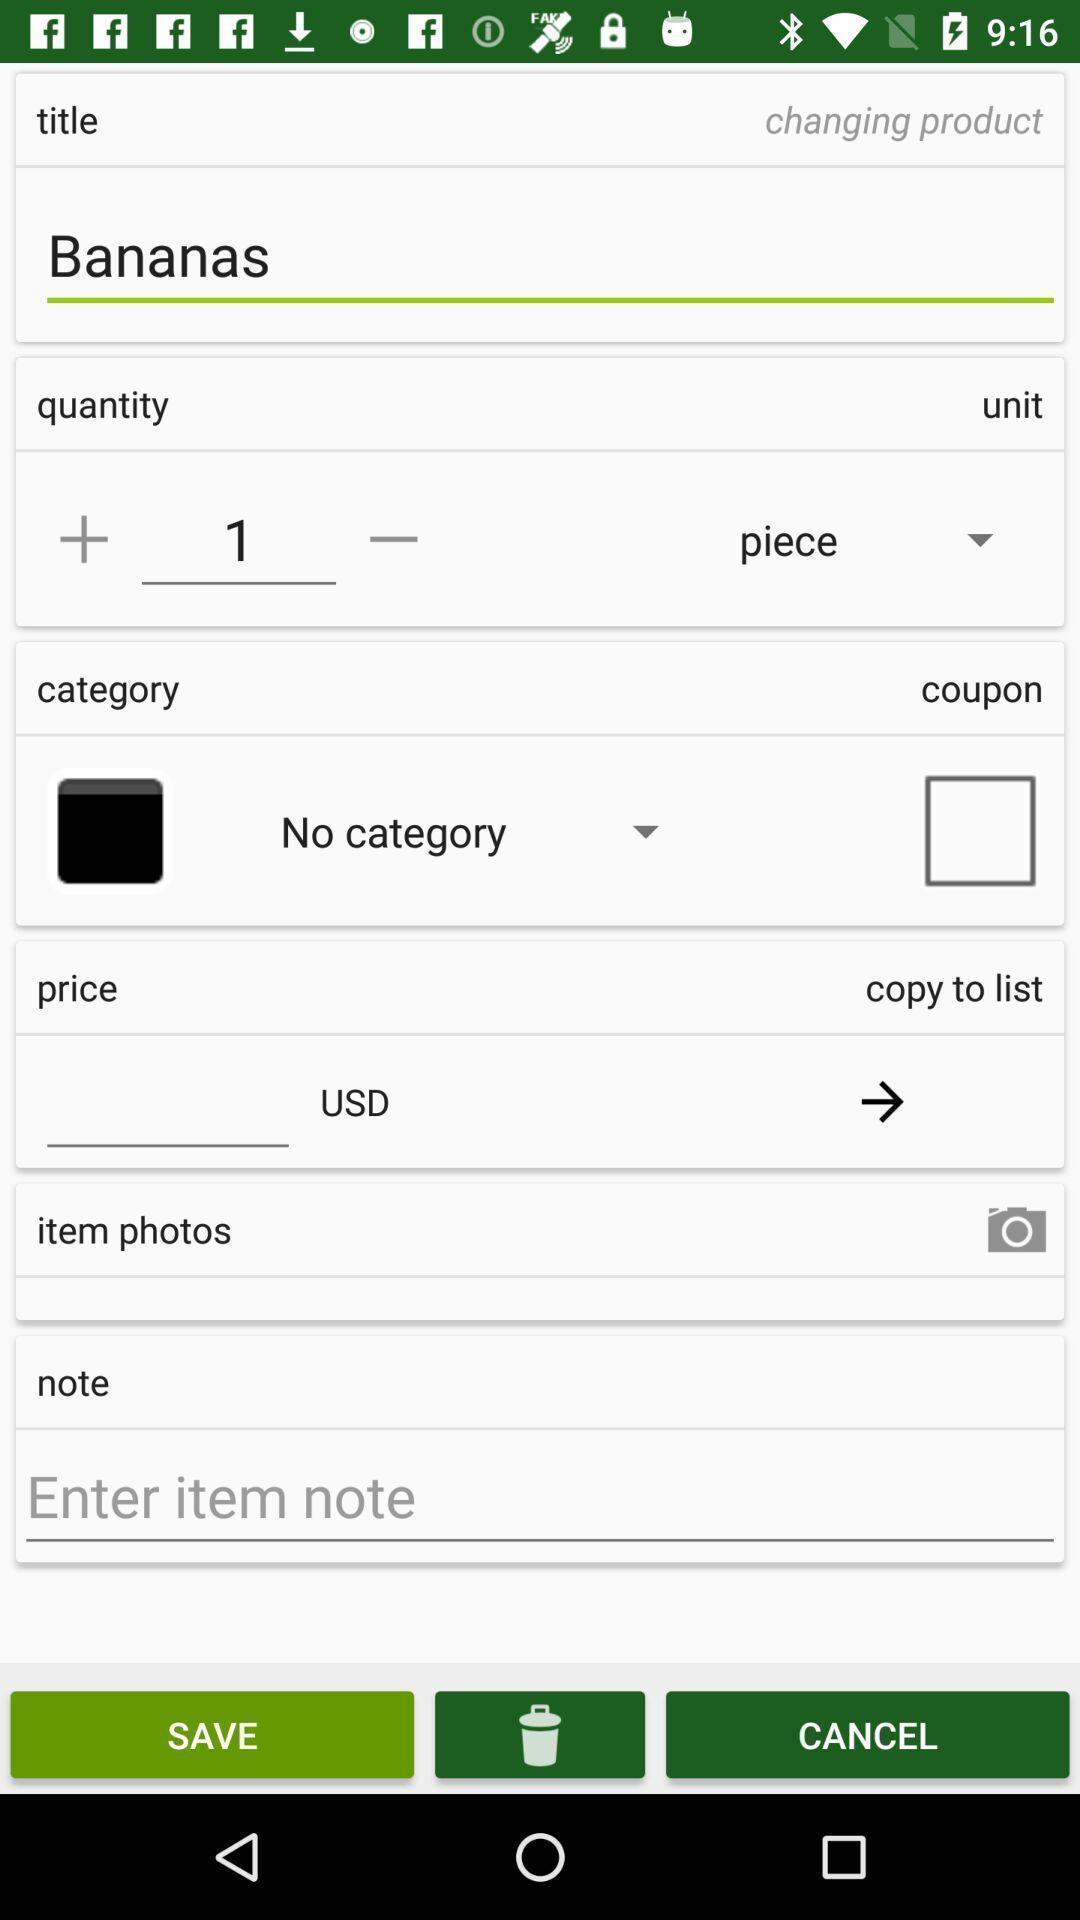Describe the content in this image. Screen displaying multiple options in a product page. 